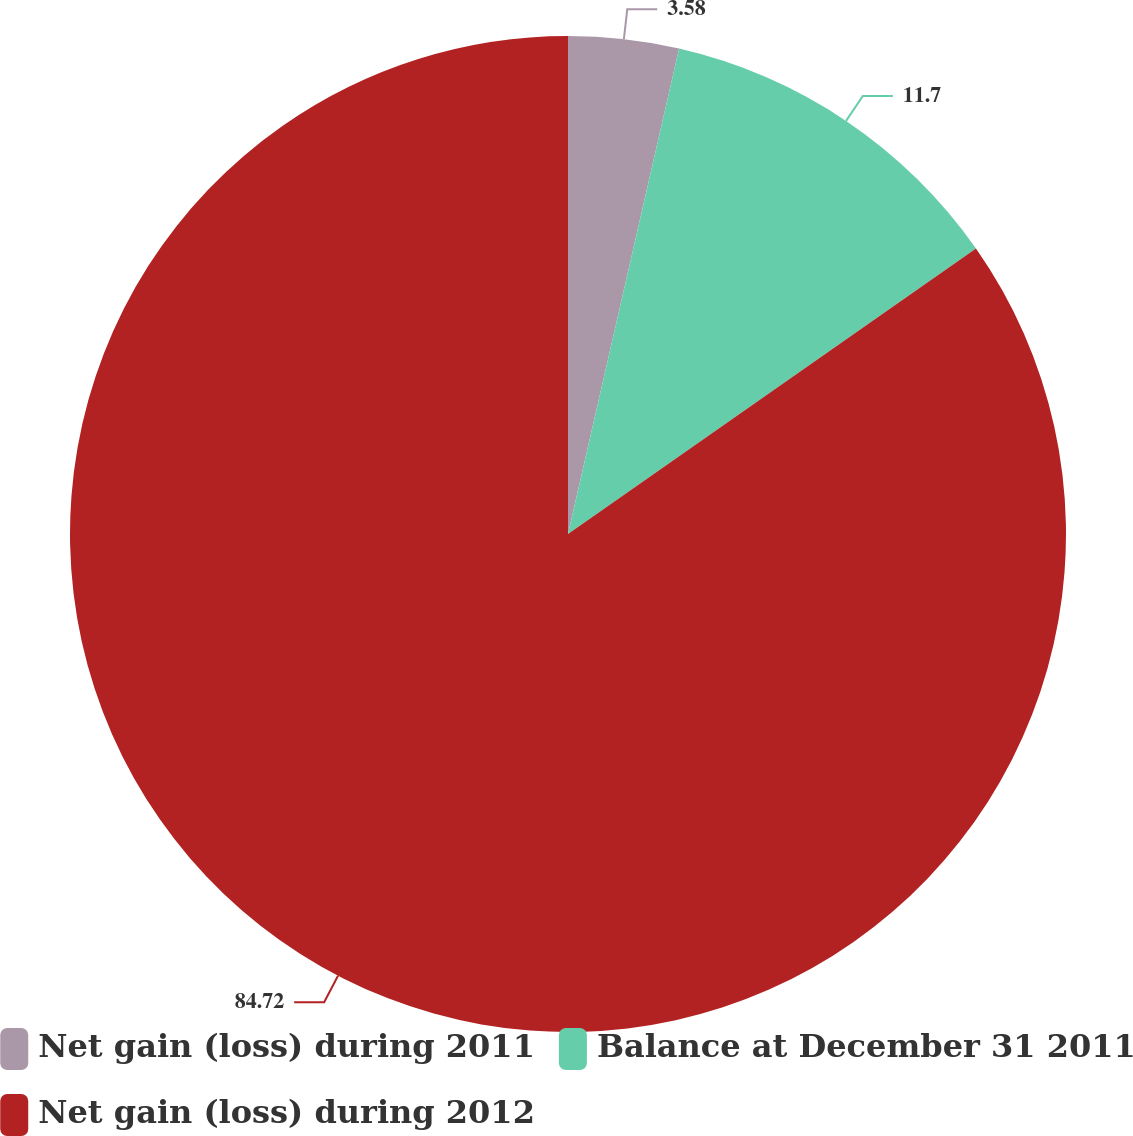Convert chart. <chart><loc_0><loc_0><loc_500><loc_500><pie_chart><fcel>Net gain (loss) during 2011<fcel>Balance at December 31 2011<fcel>Net gain (loss) during 2012<nl><fcel>3.58%<fcel>11.7%<fcel>84.72%<nl></chart> 